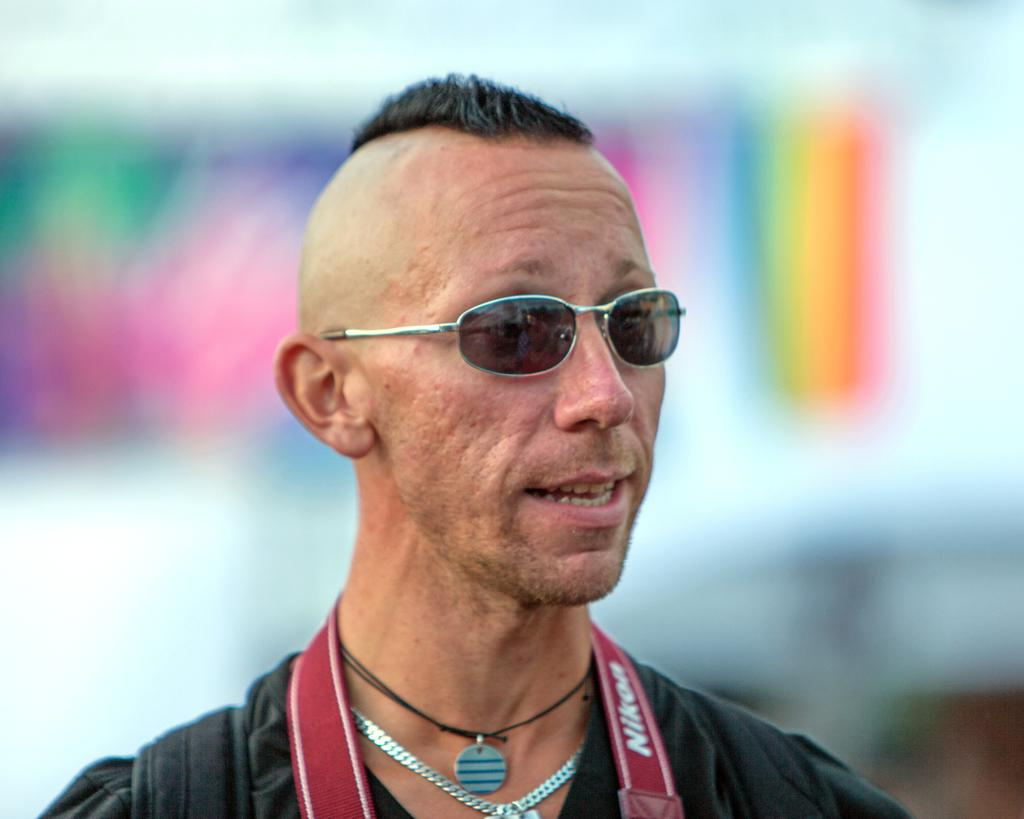Who is the person in the image? There is a man in the image. What is the man wearing? The man is wearing a black dress. Are there any accessories visible on the man? Yes, the man has chains on his neck. What type of eyewear is the man wearing? The man is wearing glasses. How would you describe the background of the image? The background of the image is blurry. What type of sail can be seen on the man's flesh in the image? There is no sail present in the image, nor is there any reference to the man's flesh. 